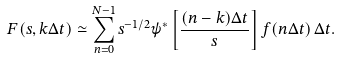Convert formula to latex. <formula><loc_0><loc_0><loc_500><loc_500>F ( s , k \Delta t ) \simeq \sum _ { n = 0 } ^ { N - 1 } s ^ { - 1 / 2 } \psi ^ { * } \left [ \frac { ( n - k ) \Delta t } { s } \right ] f ( n \Delta t ) \, \Delta t .</formula> 